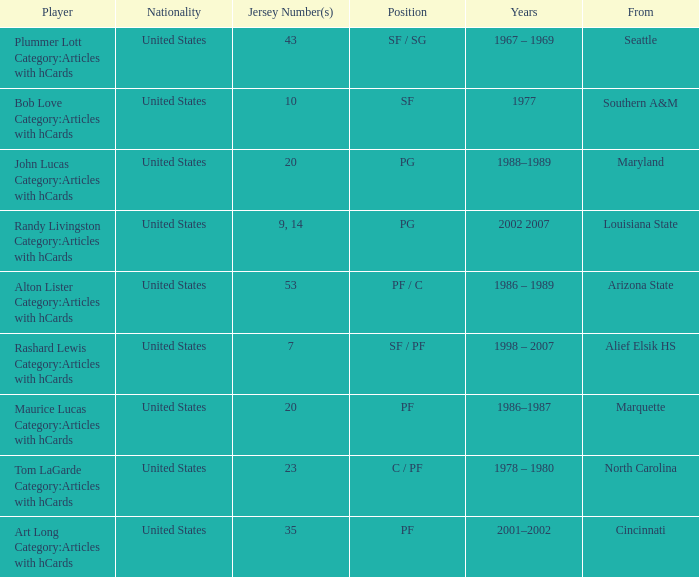Tom Lagarde Category:Articles with hCards used what Jersey Number(s)? 23.0. 